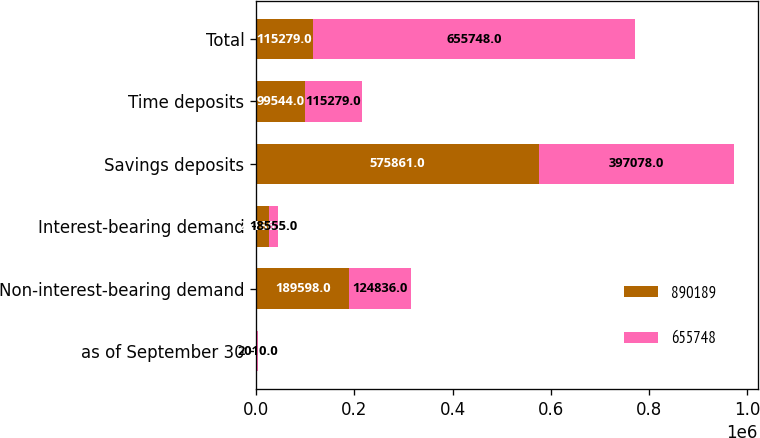Convert chart. <chart><loc_0><loc_0><loc_500><loc_500><stacked_bar_chart><ecel><fcel>as of September 30<fcel>Non-interest-bearing demand<fcel>Interest-bearing demand<fcel>Savings deposits<fcel>Time deposits<fcel>Total<nl><fcel>890189<fcel>2011<fcel>189598<fcel>25186<fcel>575861<fcel>99544<fcel>115279<nl><fcel>655748<fcel>2010<fcel>124836<fcel>18555<fcel>397078<fcel>115279<fcel>655748<nl></chart> 